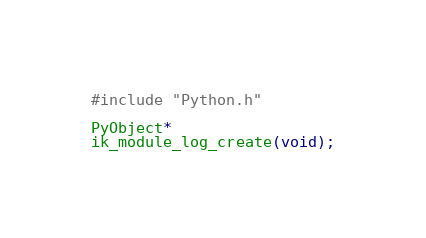<code> <loc_0><loc_0><loc_500><loc_500><_C_>#include "Python.h"

PyObject*
ik_module_log_create(void);
</code> 